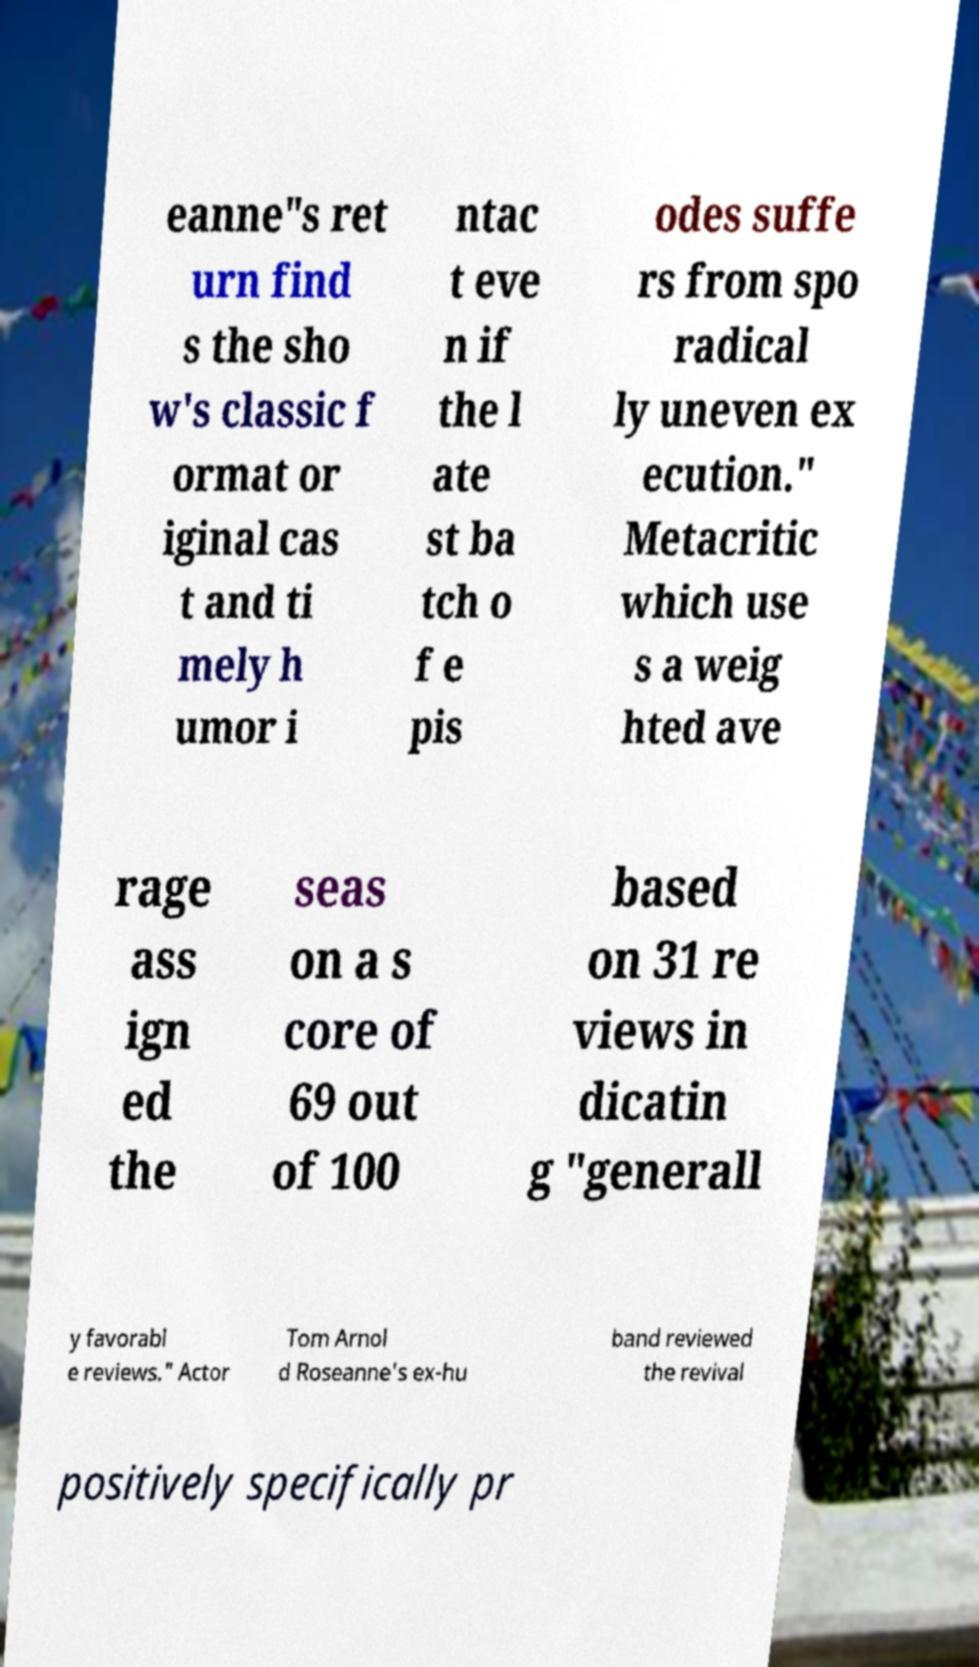Please identify and transcribe the text found in this image. eanne"s ret urn find s the sho w's classic f ormat or iginal cas t and ti mely h umor i ntac t eve n if the l ate st ba tch o f e pis odes suffe rs from spo radical ly uneven ex ecution." Metacritic which use s a weig hted ave rage ass ign ed the seas on a s core of 69 out of 100 based on 31 re views in dicatin g "generall y favorabl e reviews." Actor Tom Arnol d Roseanne's ex-hu band reviewed the revival positively specifically pr 